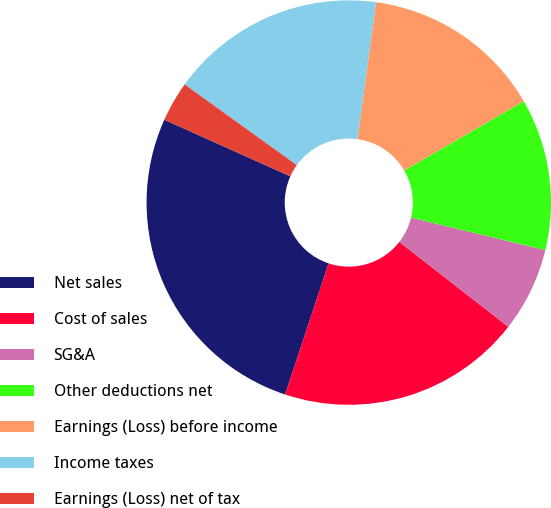Convert chart. <chart><loc_0><loc_0><loc_500><loc_500><pie_chart><fcel>Net sales<fcel>Cost of sales<fcel>SG&A<fcel>Other deductions net<fcel>Earnings (Loss) before income<fcel>Income taxes<fcel>Earnings (Loss) net of tax<nl><fcel>26.62%<fcel>19.57%<fcel>6.75%<fcel>12.14%<fcel>14.48%<fcel>17.23%<fcel>3.21%<nl></chart> 